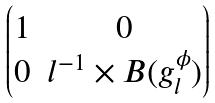Convert formula to latex. <formula><loc_0><loc_0><loc_500><loc_500>\begin{pmatrix} 1 & { 0 } \\ { 0 } & l ^ { - 1 } \times B ( g _ { l } ^ { \phi } ) \end{pmatrix}</formula> 